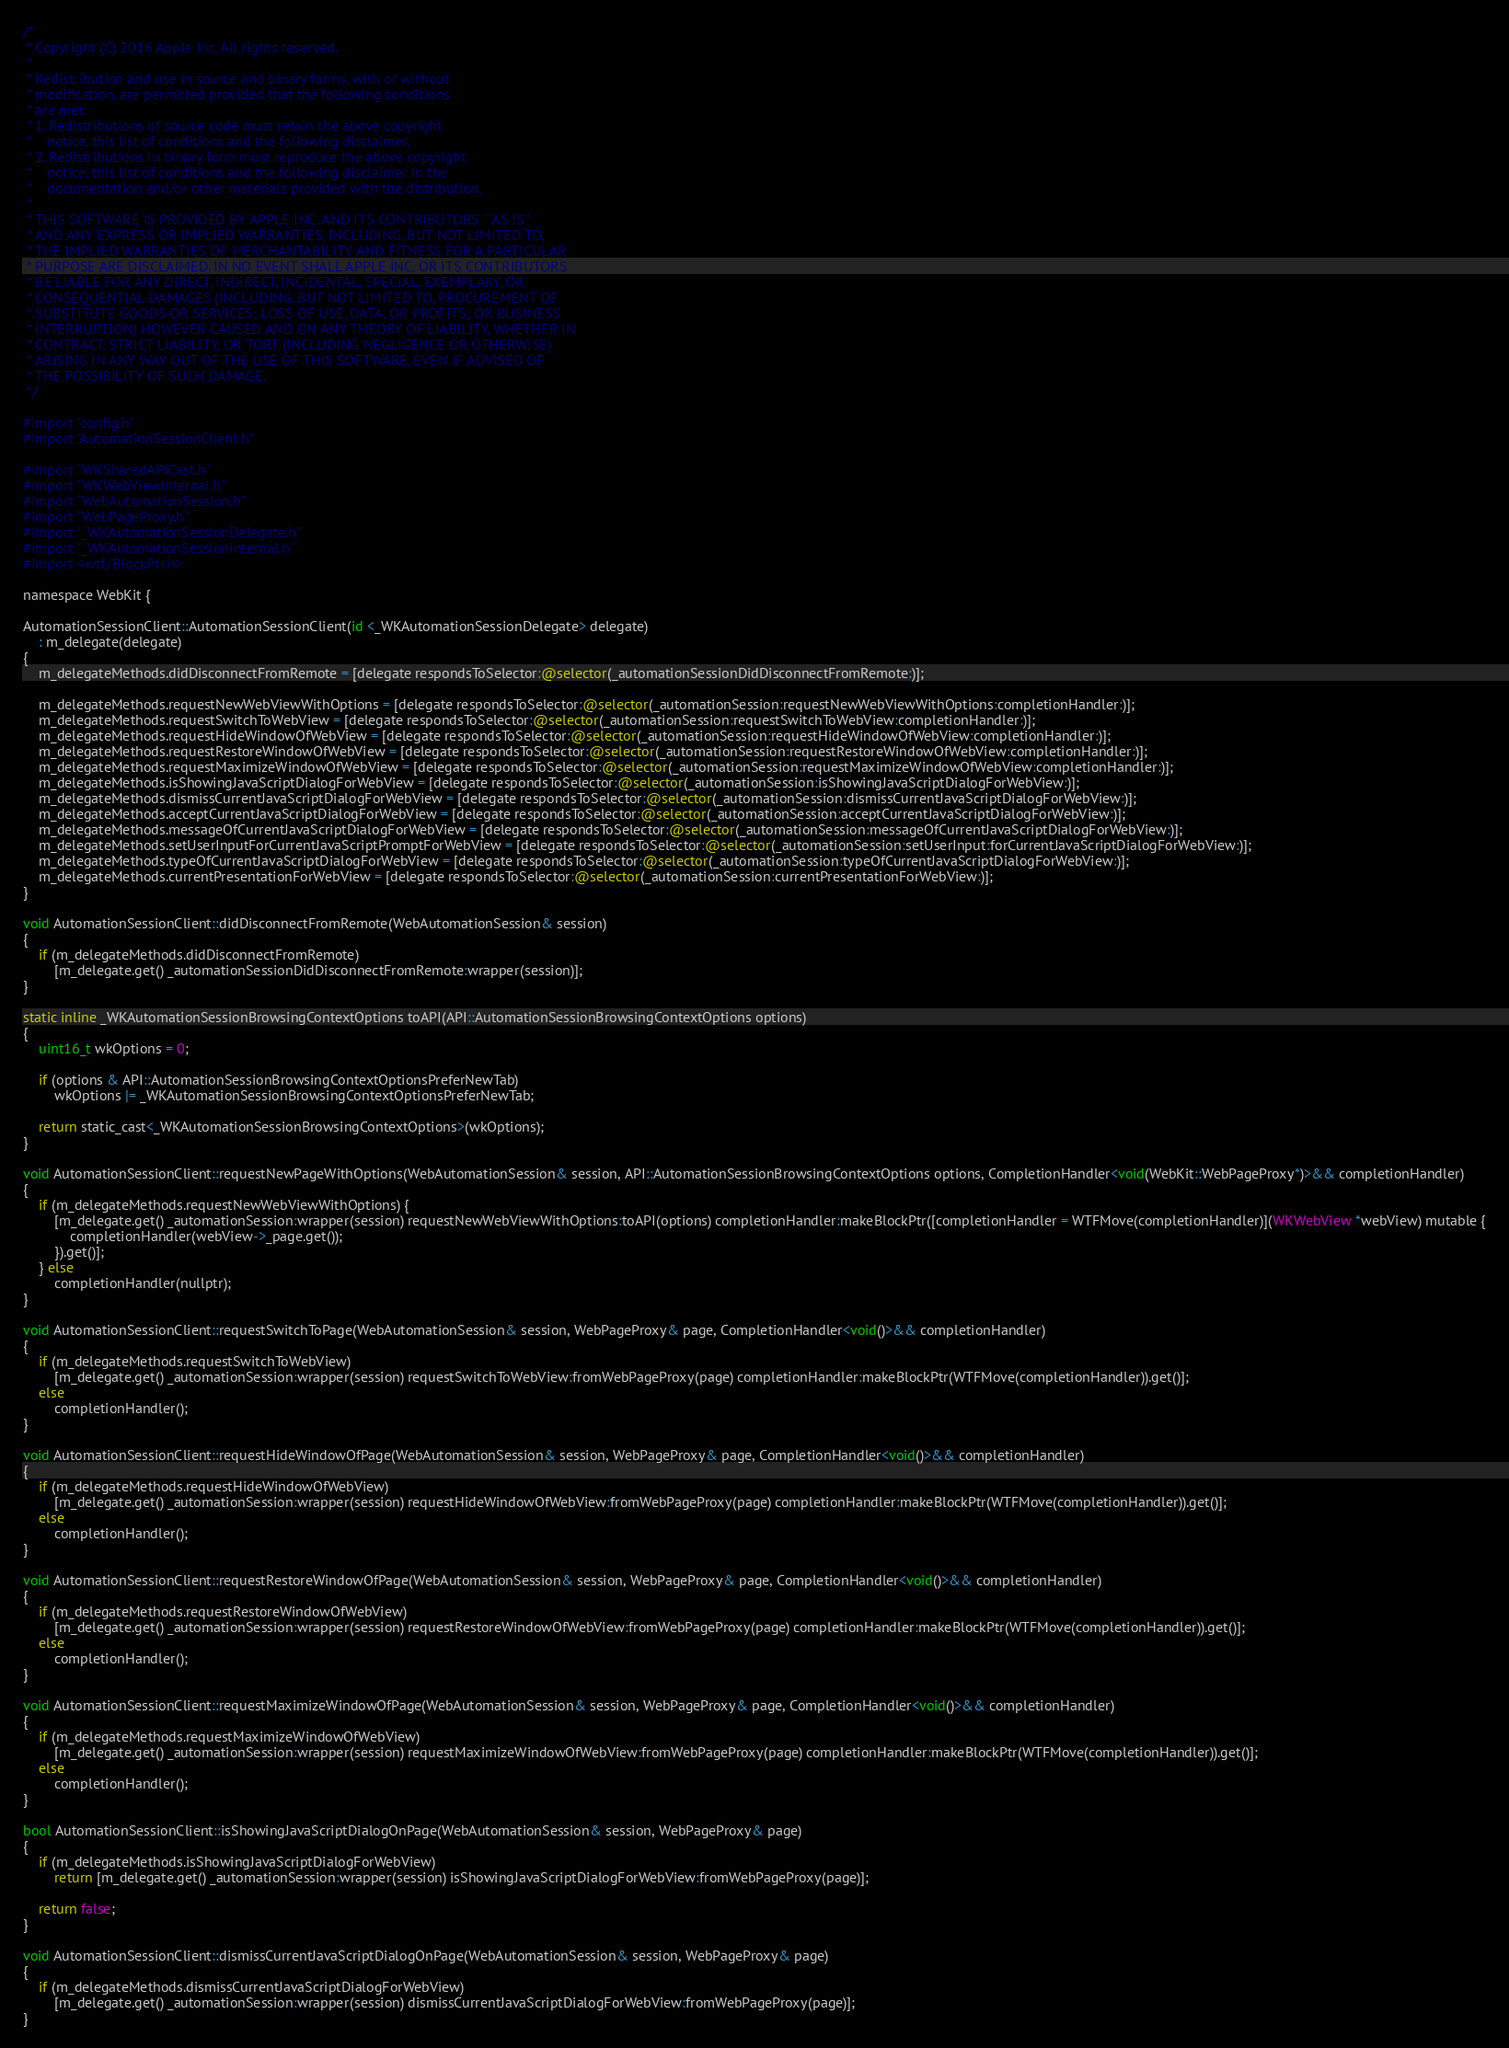<code> <loc_0><loc_0><loc_500><loc_500><_ObjectiveC_>/*
 * Copyright (C) 2016 Apple Inc. All rights reserved.
 *
 * Redistribution and use in source and binary forms, with or without
 * modification, are permitted provided that the following conditions
 * are met:
 * 1. Redistributions of source code must retain the above copyright
 *    notice, this list of conditions and the following disclaimer.
 * 2. Redistributions in binary form must reproduce the above copyright
 *    notice, this list of conditions and the following disclaimer in the
 *    documentation and/or other materials provided with the distribution.
 *
 * THIS SOFTWARE IS PROVIDED BY APPLE INC. AND ITS CONTRIBUTORS ``AS IS''
 * AND ANY EXPRESS OR IMPLIED WARRANTIES, INCLUDING, BUT NOT LIMITED TO,
 * THE IMPLIED WARRANTIES OF MERCHANTABILITY AND FITNESS FOR A PARTICULAR
 * PURPOSE ARE DISCLAIMED. IN NO EVENT SHALL APPLE INC. OR ITS CONTRIBUTORS
 * BE LIABLE FOR ANY DIRECT, INDIRECT, INCIDENTAL, SPECIAL, EXEMPLARY, OR
 * CONSEQUENTIAL DAMAGES (INCLUDING, BUT NOT LIMITED TO, PROCUREMENT OF
 * SUBSTITUTE GOODS OR SERVICES; LOSS OF USE, DATA, OR PROFITS; OR BUSINESS
 * INTERRUPTION) HOWEVER CAUSED AND ON ANY THEORY OF LIABILITY, WHETHER IN
 * CONTRACT, STRICT LIABILITY, OR TORT (INCLUDING NEGLIGENCE OR OTHERWISE)
 * ARISING IN ANY WAY OUT OF THE USE OF THIS SOFTWARE, EVEN IF ADVISED OF
 * THE POSSIBILITY OF SUCH DAMAGE.
 */

#import "config.h"
#import "AutomationSessionClient.h"

#import "WKSharedAPICast.h"
#import "WKWebViewInternal.h"
#import "WebAutomationSession.h"
#import "WebPageProxy.h"
#import "_WKAutomationSessionDelegate.h"
#import "_WKAutomationSessionInternal.h"
#import <wtf/BlockPtr.h>

namespace WebKit {

AutomationSessionClient::AutomationSessionClient(id <_WKAutomationSessionDelegate> delegate)
    : m_delegate(delegate)
{
    m_delegateMethods.didDisconnectFromRemote = [delegate respondsToSelector:@selector(_automationSessionDidDisconnectFromRemote:)];

    m_delegateMethods.requestNewWebViewWithOptions = [delegate respondsToSelector:@selector(_automationSession:requestNewWebViewWithOptions:completionHandler:)];
    m_delegateMethods.requestSwitchToWebView = [delegate respondsToSelector:@selector(_automationSession:requestSwitchToWebView:completionHandler:)];
    m_delegateMethods.requestHideWindowOfWebView = [delegate respondsToSelector:@selector(_automationSession:requestHideWindowOfWebView:completionHandler:)];
    m_delegateMethods.requestRestoreWindowOfWebView = [delegate respondsToSelector:@selector(_automationSession:requestRestoreWindowOfWebView:completionHandler:)];
    m_delegateMethods.requestMaximizeWindowOfWebView = [delegate respondsToSelector:@selector(_automationSession:requestMaximizeWindowOfWebView:completionHandler:)];
    m_delegateMethods.isShowingJavaScriptDialogForWebView = [delegate respondsToSelector:@selector(_automationSession:isShowingJavaScriptDialogForWebView:)];
    m_delegateMethods.dismissCurrentJavaScriptDialogForWebView = [delegate respondsToSelector:@selector(_automationSession:dismissCurrentJavaScriptDialogForWebView:)];
    m_delegateMethods.acceptCurrentJavaScriptDialogForWebView = [delegate respondsToSelector:@selector(_automationSession:acceptCurrentJavaScriptDialogForWebView:)];
    m_delegateMethods.messageOfCurrentJavaScriptDialogForWebView = [delegate respondsToSelector:@selector(_automationSession:messageOfCurrentJavaScriptDialogForWebView:)];
    m_delegateMethods.setUserInputForCurrentJavaScriptPromptForWebView = [delegate respondsToSelector:@selector(_automationSession:setUserInput:forCurrentJavaScriptDialogForWebView:)];
    m_delegateMethods.typeOfCurrentJavaScriptDialogForWebView = [delegate respondsToSelector:@selector(_automationSession:typeOfCurrentJavaScriptDialogForWebView:)];
    m_delegateMethods.currentPresentationForWebView = [delegate respondsToSelector:@selector(_automationSession:currentPresentationForWebView:)];
}

void AutomationSessionClient::didDisconnectFromRemote(WebAutomationSession& session)
{
    if (m_delegateMethods.didDisconnectFromRemote)
        [m_delegate.get() _automationSessionDidDisconnectFromRemote:wrapper(session)];
}

static inline _WKAutomationSessionBrowsingContextOptions toAPI(API::AutomationSessionBrowsingContextOptions options)
{
    uint16_t wkOptions = 0;

    if (options & API::AutomationSessionBrowsingContextOptionsPreferNewTab)
        wkOptions |= _WKAutomationSessionBrowsingContextOptionsPreferNewTab;

    return static_cast<_WKAutomationSessionBrowsingContextOptions>(wkOptions);
}

void AutomationSessionClient::requestNewPageWithOptions(WebAutomationSession& session, API::AutomationSessionBrowsingContextOptions options, CompletionHandler<void(WebKit::WebPageProxy*)>&& completionHandler)
{
    if (m_delegateMethods.requestNewWebViewWithOptions) {
        [m_delegate.get() _automationSession:wrapper(session) requestNewWebViewWithOptions:toAPI(options) completionHandler:makeBlockPtr([completionHandler = WTFMove(completionHandler)](WKWebView *webView) mutable {
            completionHandler(webView->_page.get());
        }).get()];
    } else
        completionHandler(nullptr);
}

void AutomationSessionClient::requestSwitchToPage(WebAutomationSession& session, WebPageProxy& page, CompletionHandler<void()>&& completionHandler)
{
    if (m_delegateMethods.requestSwitchToWebView)
        [m_delegate.get() _automationSession:wrapper(session) requestSwitchToWebView:fromWebPageProxy(page) completionHandler:makeBlockPtr(WTFMove(completionHandler)).get()];
    else
        completionHandler();
}

void AutomationSessionClient::requestHideWindowOfPage(WebAutomationSession& session, WebPageProxy& page, CompletionHandler<void()>&& completionHandler)
{
    if (m_delegateMethods.requestHideWindowOfWebView)
        [m_delegate.get() _automationSession:wrapper(session) requestHideWindowOfWebView:fromWebPageProxy(page) completionHandler:makeBlockPtr(WTFMove(completionHandler)).get()];
    else
        completionHandler();
}

void AutomationSessionClient::requestRestoreWindowOfPage(WebAutomationSession& session, WebPageProxy& page, CompletionHandler<void()>&& completionHandler)
{
    if (m_delegateMethods.requestRestoreWindowOfWebView)
        [m_delegate.get() _automationSession:wrapper(session) requestRestoreWindowOfWebView:fromWebPageProxy(page) completionHandler:makeBlockPtr(WTFMove(completionHandler)).get()];
    else
        completionHandler();
}

void AutomationSessionClient::requestMaximizeWindowOfPage(WebAutomationSession& session, WebPageProxy& page, CompletionHandler<void()>&& completionHandler)
{
    if (m_delegateMethods.requestMaximizeWindowOfWebView)
        [m_delegate.get() _automationSession:wrapper(session) requestMaximizeWindowOfWebView:fromWebPageProxy(page) completionHandler:makeBlockPtr(WTFMove(completionHandler)).get()];
    else
        completionHandler();
}

bool AutomationSessionClient::isShowingJavaScriptDialogOnPage(WebAutomationSession& session, WebPageProxy& page)
{
    if (m_delegateMethods.isShowingJavaScriptDialogForWebView)
        return [m_delegate.get() _automationSession:wrapper(session) isShowingJavaScriptDialogForWebView:fromWebPageProxy(page)];
    
    return false;
}

void AutomationSessionClient::dismissCurrentJavaScriptDialogOnPage(WebAutomationSession& session, WebPageProxy& page)
{
    if (m_delegateMethods.dismissCurrentJavaScriptDialogForWebView)
        [m_delegate.get() _automationSession:wrapper(session) dismissCurrentJavaScriptDialogForWebView:fromWebPageProxy(page)];
}
</code> 